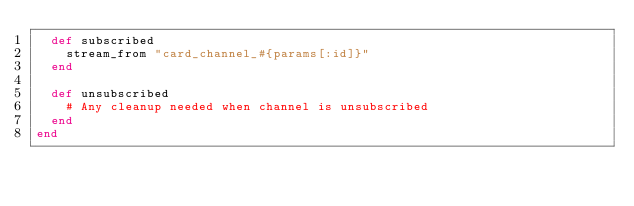Convert code to text. <code><loc_0><loc_0><loc_500><loc_500><_Ruby_>  def subscribed
    stream_from "card_channel_#{params[:id]}"
  end

  def unsubscribed
    # Any cleanup needed when channel is unsubscribed
  end
end
</code> 